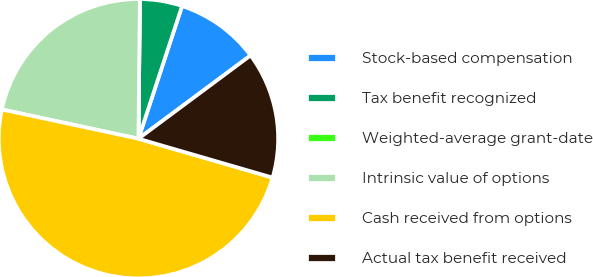Convert chart. <chart><loc_0><loc_0><loc_500><loc_500><pie_chart><fcel>Stock-based compensation<fcel>Tax benefit recognized<fcel>Weighted-average grant-date<fcel>Intrinsic value of options<fcel>Cash received from options<fcel>Actual tax benefit received<nl><fcel>9.78%<fcel>4.89%<fcel>0.0%<fcel>21.81%<fcel>48.87%<fcel>14.66%<nl></chart> 